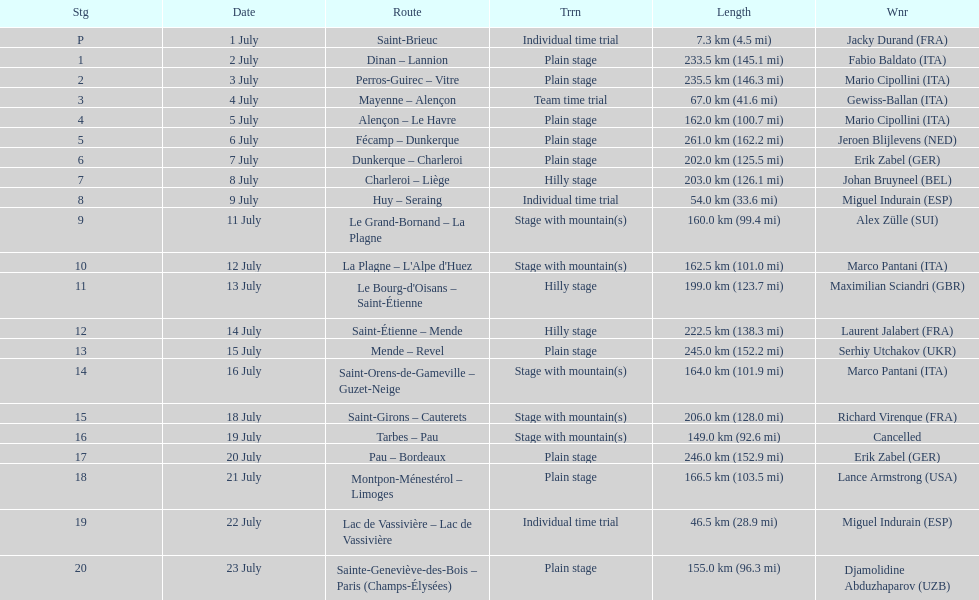Could you help me parse every detail presented in this table? {'header': ['Stg', 'Date', 'Route', 'Trrn', 'Length', 'Wnr'], 'rows': [['P', '1 July', 'Saint-Brieuc', 'Individual time trial', '7.3\xa0km (4.5\xa0mi)', 'Jacky Durand\xa0(FRA)'], ['1', '2 July', 'Dinan – Lannion', 'Plain stage', '233.5\xa0km (145.1\xa0mi)', 'Fabio Baldato\xa0(ITA)'], ['2', '3 July', 'Perros-Guirec – Vitre', 'Plain stage', '235.5\xa0km (146.3\xa0mi)', 'Mario Cipollini\xa0(ITA)'], ['3', '4 July', 'Mayenne – Alençon', 'Team time trial', '67.0\xa0km (41.6\xa0mi)', 'Gewiss-Ballan\xa0(ITA)'], ['4', '5 July', 'Alençon – Le Havre', 'Plain stage', '162.0\xa0km (100.7\xa0mi)', 'Mario Cipollini\xa0(ITA)'], ['5', '6 July', 'Fécamp – Dunkerque', 'Plain stage', '261.0\xa0km (162.2\xa0mi)', 'Jeroen Blijlevens\xa0(NED)'], ['6', '7 July', 'Dunkerque – Charleroi', 'Plain stage', '202.0\xa0km (125.5\xa0mi)', 'Erik Zabel\xa0(GER)'], ['7', '8 July', 'Charleroi – Liège', 'Hilly stage', '203.0\xa0km (126.1\xa0mi)', 'Johan Bruyneel\xa0(BEL)'], ['8', '9 July', 'Huy – Seraing', 'Individual time trial', '54.0\xa0km (33.6\xa0mi)', 'Miguel Indurain\xa0(ESP)'], ['9', '11 July', 'Le Grand-Bornand – La Plagne', 'Stage with mountain(s)', '160.0\xa0km (99.4\xa0mi)', 'Alex Zülle\xa0(SUI)'], ['10', '12 July', "La Plagne – L'Alpe d'Huez", 'Stage with mountain(s)', '162.5\xa0km (101.0\xa0mi)', 'Marco Pantani\xa0(ITA)'], ['11', '13 July', "Le Bourg-d'Oisans – Saint-Étienne", 'Hilly stage', '199.0\xa0km (123.7\xa0mi)', 'Maximilian Sciandri\xa0(GBR)'], ['12', '14 July', 'Saint-Étienne – Mende', 'Hilly stage', '222.5\xa0km (138.3\xa0mi)', 'Laurent Jalabert\xa0(FRA)'], ['13', '15 July', 'Mende – Revel', 'Plain stage', '245.0\xa0km (152.2\xa0mi)', 'Serhiy Utchakov\xa0(UKR)'], ['14', '16 July', 'Saint-Orens-de-Gameville – Guzet-Neige', 'Stage with mountain(s)', '164.0\xa0km (101.9\xa0mi)', 'Marco Pantani\xa0(ITA)'], ['15', '18 July', 'Saint-Girons – Cauterets', 'Stage with mountain(s)', '206.0\xa0km (128.0\xa0mi)', 'Richard Virenque\xa0(FRA)'], ['16', '19 July', 'Tarbes – Pau', 'Stage with mountain(s)', '149.0\xa0km (92.6\xa0mi)', 'Cancelled'], ['17', '20 July', 'Pau – Bordeaux', 'Plain stage', '246.0\xa0km (152.9\xa0mi)', 'Erik Zabel\xa0(GER)'], ['18', '21 July', 'Montpon-Ménestérol – Limoges', 'Plain stage', '166.5\xa0km (103.5\xa0mi)', 'Lance Armstrong\xa0(USA)'], ['19', '22 July', 'Lac de Vassivière – Lac de Vassivière', 'Individual time trial', '46.5\xa0km (28.9\xa0mi)', 'Miguel Indurain\xa0(ESP)'], ['20', '23 July', 'Sainte-Geneviève-des-Bois – Paris (Champs-Élysées)', 'Plain stage', '155.0\xa0km (96.3\xa0mi)', 'Djamolidine Abduzhaparov\xa0(UZB)']]} Which country had more stage-winners than any other country? Italy. 